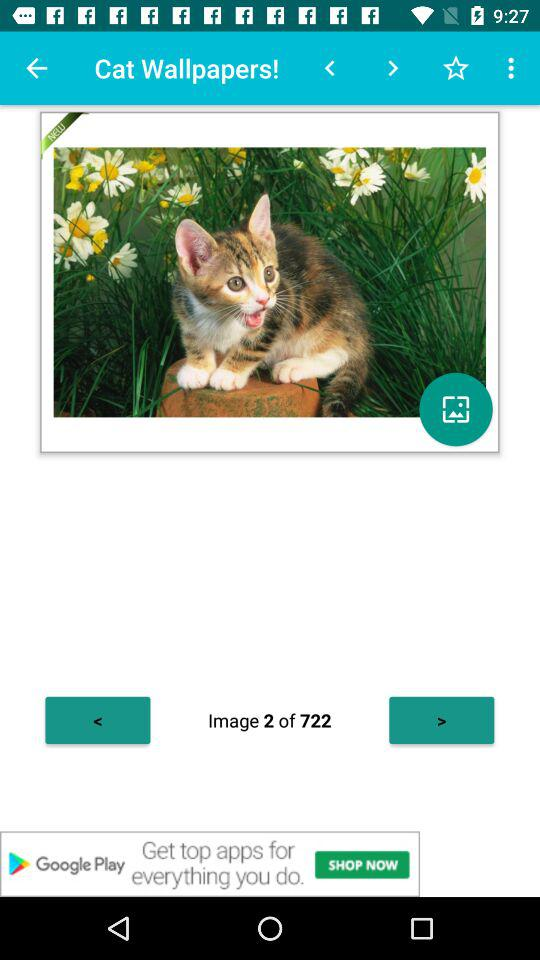How many total images are there? There are a total of 722 images. 